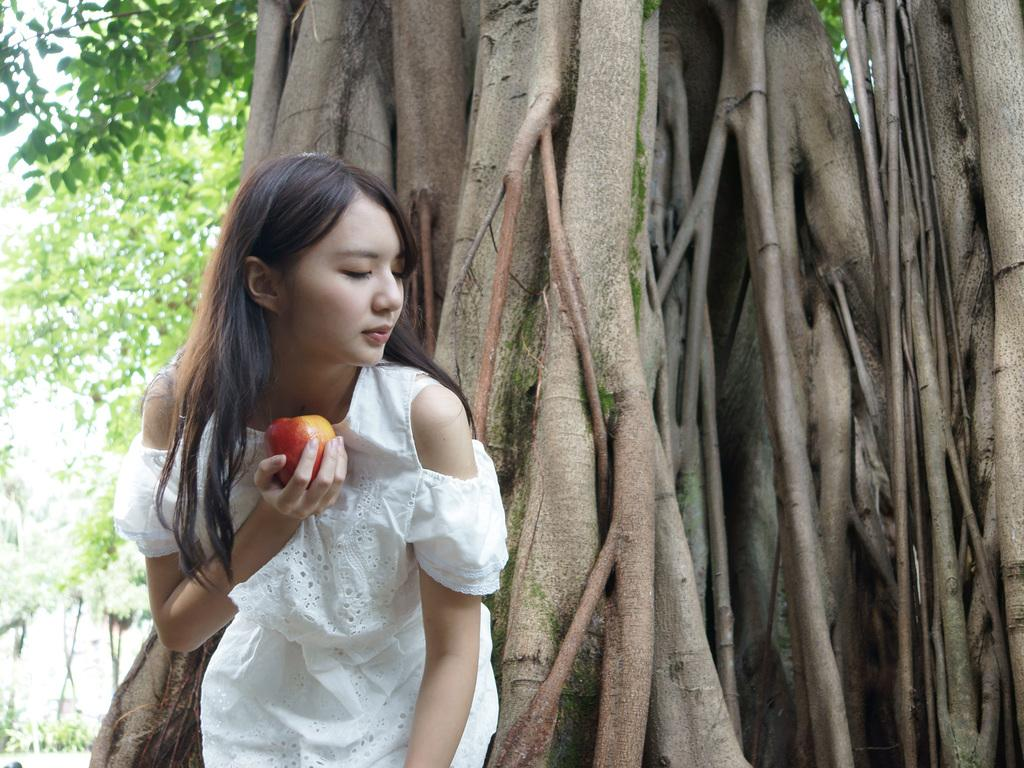What is the woman in the image doing? The woman is standing in the image. What is the woman holding in the image? The woman is holding an apple. What can be seen in the background of the image? There is a tree trunk visible in the image, and trees are on the left side of the image. How many sisters are visible in the image? There are no sisters present in the image; it only features a woman holding an apple. 